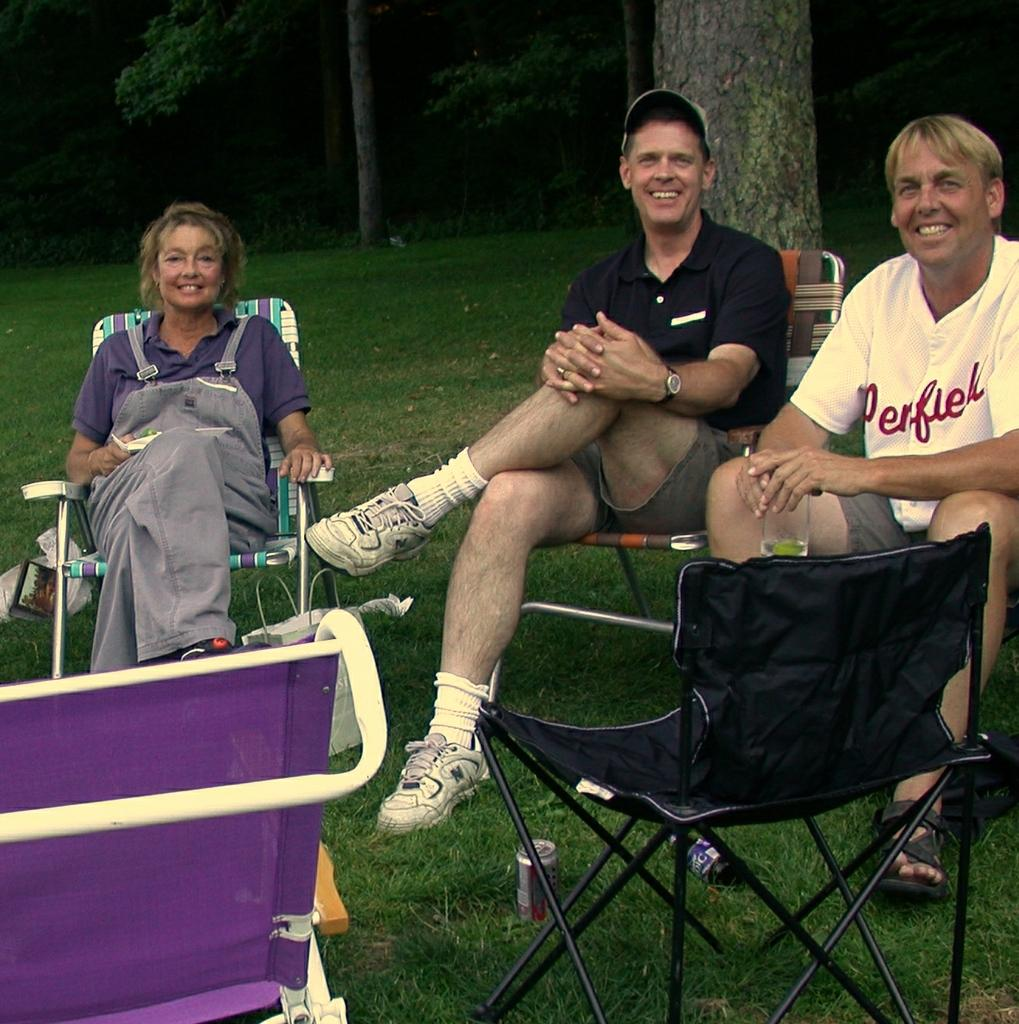How many people are in the image? There are three people in the image: one woman and two men. What are the people in the image doing? The woman and men are sitting on chairs. Are there any empty chairs in the image? Yes, there are two additional chairs in front of them. What objects can be seen on the floor in the image? There are two canes on the floor. What can be seen in the background of the image? There is a tree visible in the background. What type of straw is being exchanged between the woman and men in the image? There is no straw present in the image, and no exchange is taking place between the woman and men. 